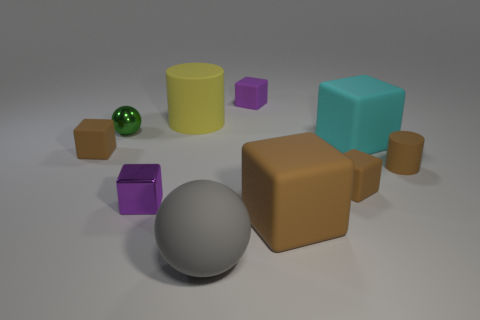Subtract all green cylinders. How many brown cubes are left? 3 Subtract all cyan cubes. How many cubes are left? 5 Subtract all metallic cubes. How many cubes are left? 5 Subtract all gray blocks. Subtract all blue balls. How many blocks are left? 6 Subtract all spheres. How many objects are left? 8 Add 4 large matte blocks. How many large matte blocks are left? 6 Add 8 big gray rubber objects. How many big gray rubber objects exist? 9 Subtract 0 yellow balls. How many objects are left? 10 Subtract all big cubes. Subtract all tiny spheres. How many objects are left? 7 